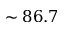Convert formula to latex. <formula><loc_0><loc_0><loc_500><loc_500>\sim 8 6 . 7</formula> 